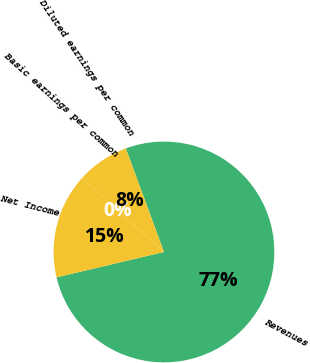Convert chart to OTSL. <chart><loc_0><loc_0><loc_500><loc_500><pie_chart><fcel>Revenues<fcel>Net Income<fcel>Basic earnings per common<fcel>Diluted earnings per common<nl><fcel>76.92%<fcel>15.38%<fcel>0.0%<fcel>7.69%<nl></chart> 